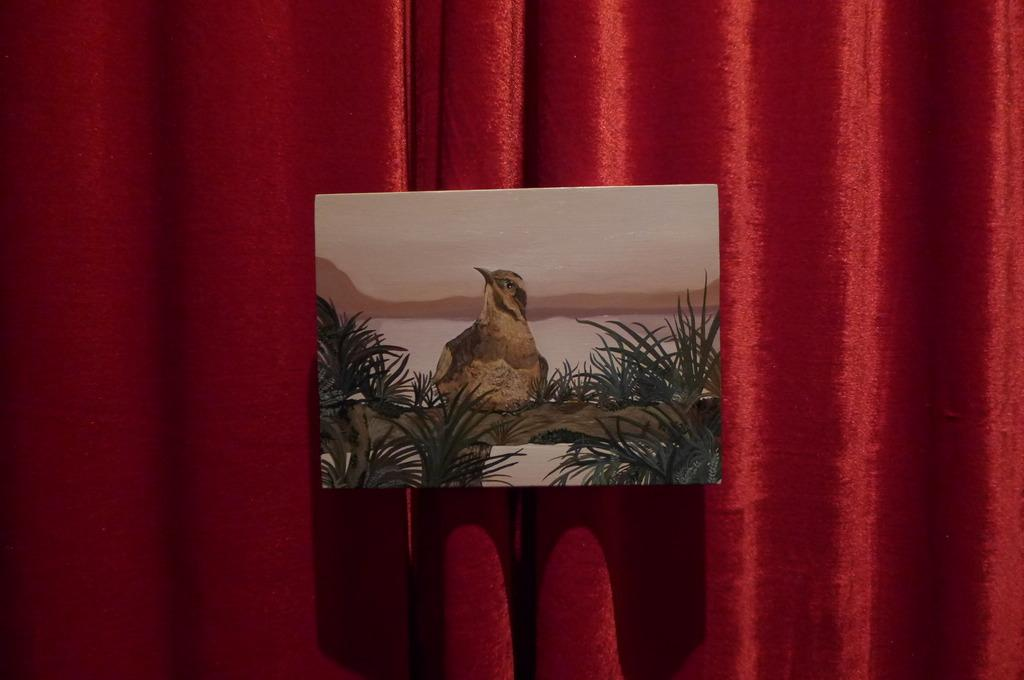What is the main subject of the painting in the image? The painting depicts a bird. What else can be seen in the painting besides the bird? The painting also depicts grass. What is the color of the curtain in the image? The curtain in the image is red. How much sugar is sprinkled on the bird in the painting? There is no sugar present in the image, as it is a painting of a bird and grass. 